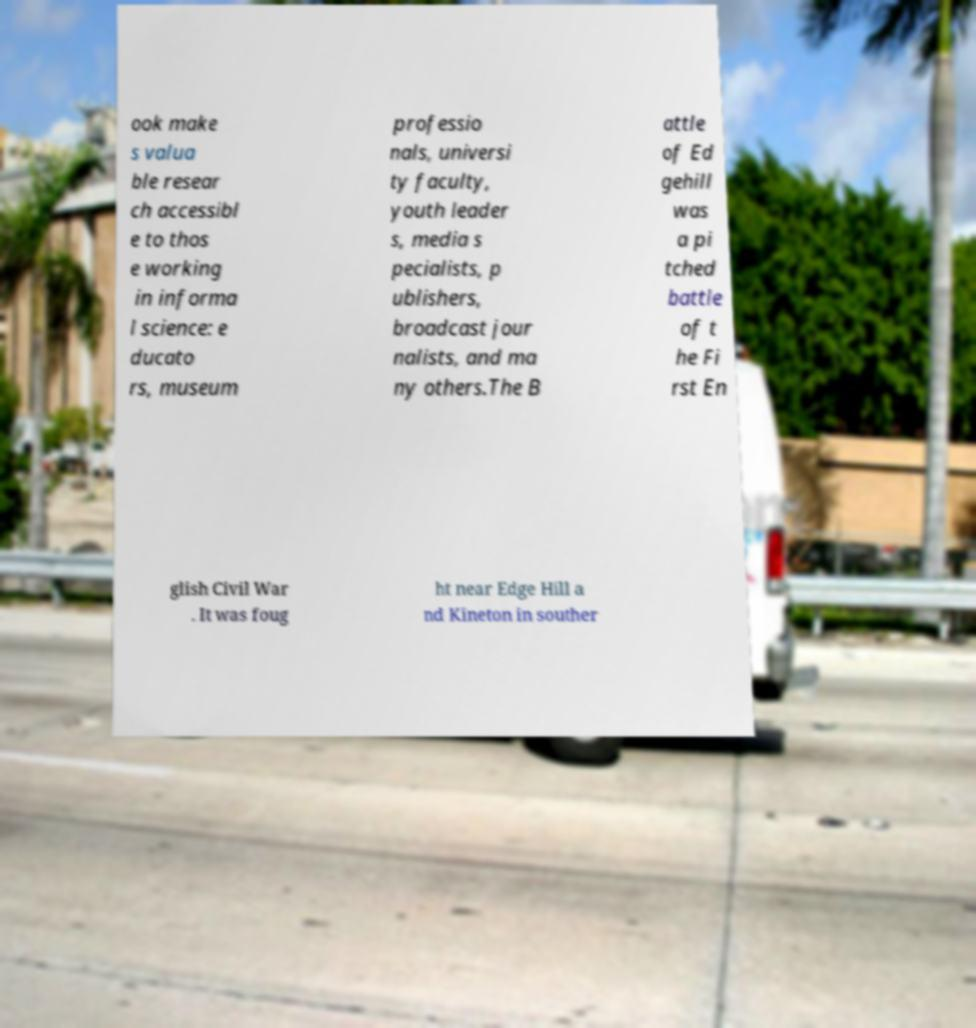What messages or text are displayed in this image? I need them in a readable, typed format. ook make s valua ble resear ch accessibl e to thos e working in informa l science: e ducato rs, museum professio nals, universi ty faculty, youth leader s, media s pecialists, p ublishers, broadcast jour nalists, and ma ny others.The B attle of Ed gehill was a pi tched battle of t he Fi rst En glish Civil War . It was foug ht near Edge Hill a nd Kineton in souther 